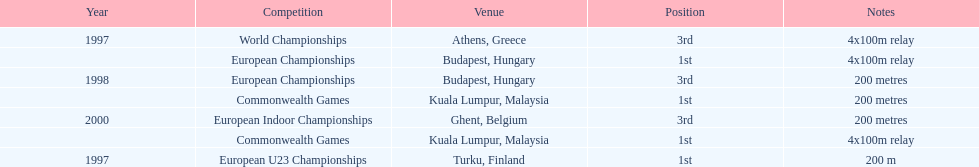What was the exclusive event achieved in belgium? European Indoor Championships. 